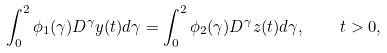<formula> <loc_0><loc_0><loc_500><loc_500>\int _ { 0 } ^ { 2 } \phi _ { 1 } ( \gamma ) D ^ { \gamma } y ( t ) d \gamma = \int _ { 0 } ^ { 2 } \phi _ { 2 } ( \gamma ) D ^ { \gamma } z ( t ) d \gamma , \quad t > 0 ,</formula> 